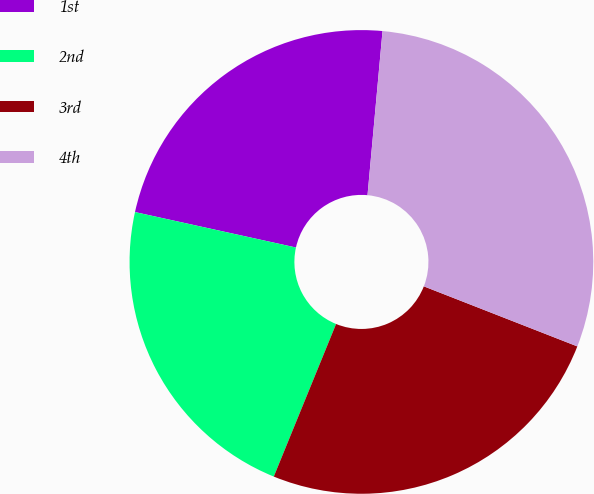Convert chart to OTSL. <chart><loc_0><loc_0><loc_500><loc_500><pie_chart><fcel>1st<fcel>2nd<fcel>3rd<fcel>4th<nl><fcel>23.0%<fcel>22.28%<fcel>25.23%<fcel>29.48%<nl></chart> 